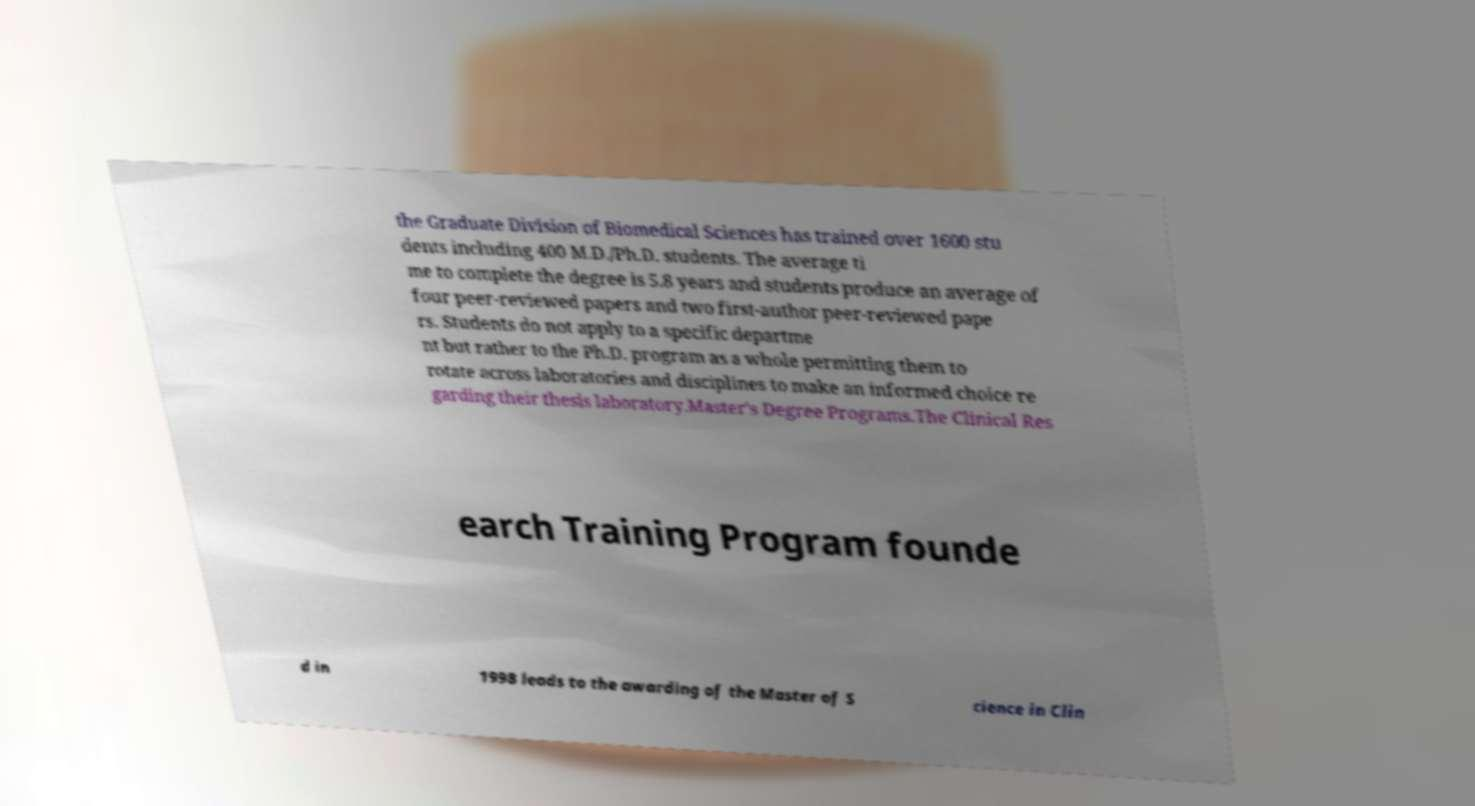There's text embedded in this image that I need extracted. Can you transcribe it verbatim? the Graduate Division of Biomedical Sciences has trained over 1600 stu dents including 400 M.D./Ph.D. students. The average ti me to complete the degree is 5.8 years and students produce an average of four peer-reviewed papers and two first-author peer-reviewed pape rs. Students do not apply to a specific departme nt but rather to the Ph.D. program as a whole permitting them to rotate across laboratories and disciplines to make an informed choice re garding their thesis laboratory.Master's Degree Programs.The Clinical Res earch Training Program founde d in 1998 leads to the awarding of the Master of S cience in Clin 